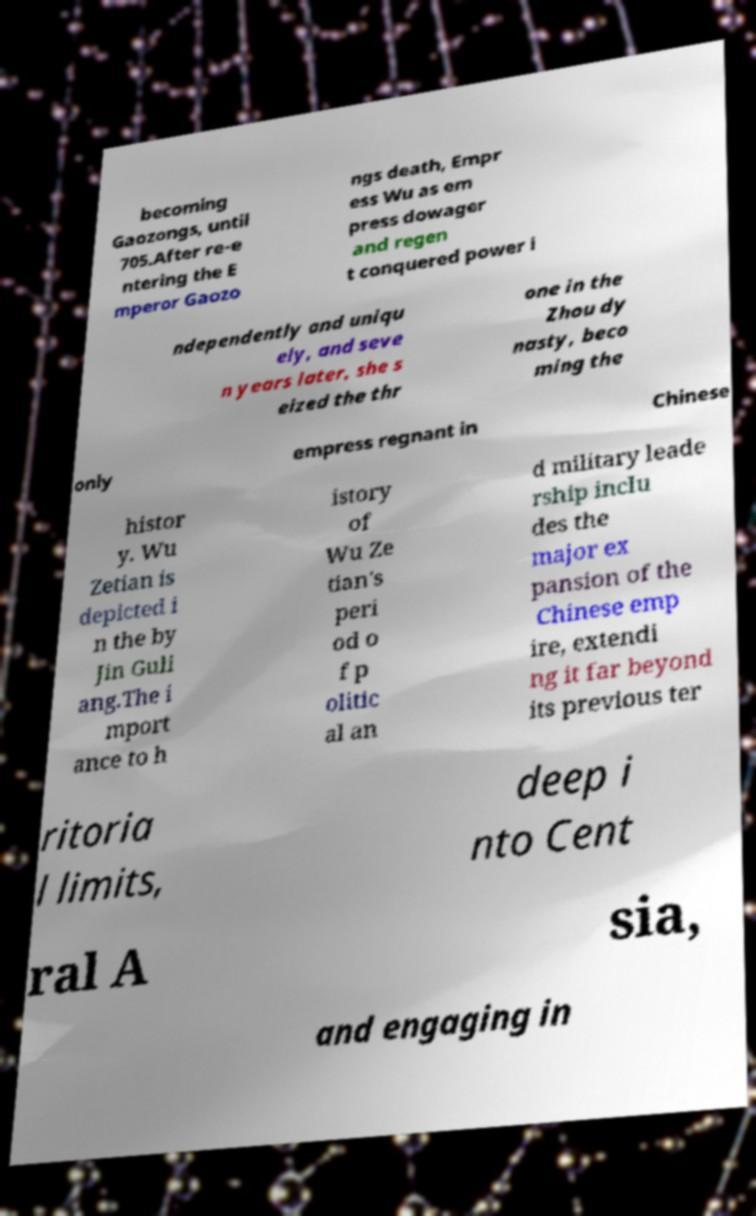For documentation purposes, I need the text within this image transcribed. Could you provide that? becoming Gaozongs, until 705.After re-e ntering the E mperor Gaozo ngs death, Empr ess Wu as em press dowager and regen t conquered power i ndependently and uniqu ely, and seve n years later, she s eized the thr one in the Zhou dy nasty, beco ming the only empress regnant in Chinese histor y. Wu Zetian is depicted i n the by Jin Guli ang.The i mport ance to h istory of Wu Ze tian's peri od o f p olitic al an d military leade rship inclu des the major ex pansion of the Chinese emp ire, extendi ng it far beyond its previous ter ritoria l limits, deep i nto Cent ral A sia, and engaging in 